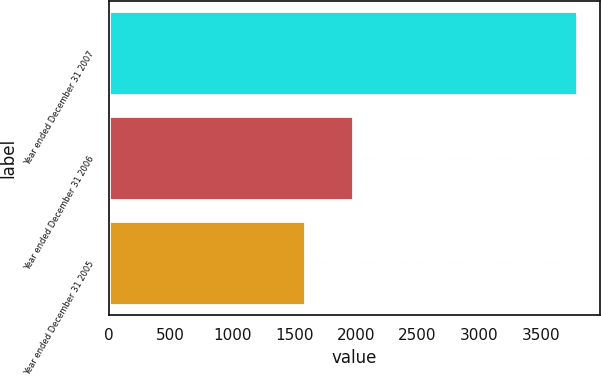Convert chart. <chart><loc_0><loc_0><loc_500><loc_500><bar_chart><fcel>Year ended December 31 2007<fcel>Year ended December 31 2006<fcel>Year ended December 31 2005<nl><fcel>3793<fcel>1978<fcel>1591<nl></chart> 